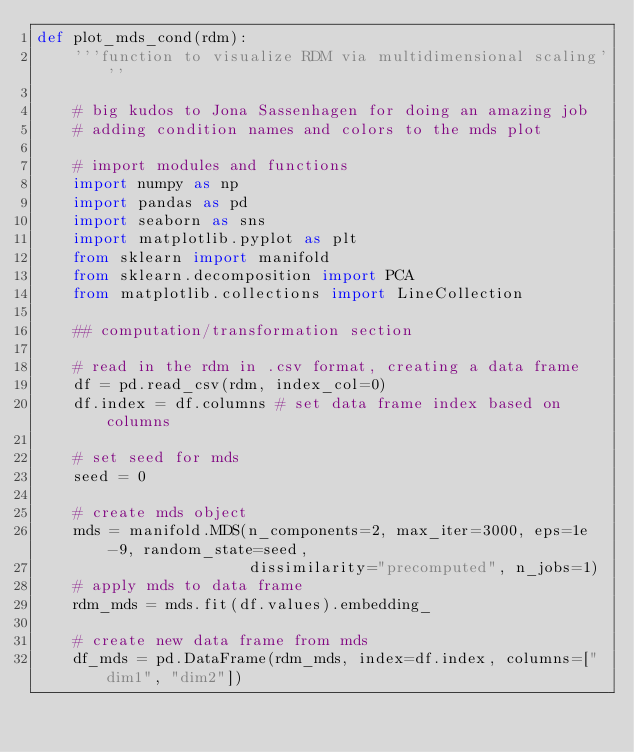Convert code to text. <code><loc_0><loc_0><loc_500><loc_500><_Python_>def plot_mds_cond(rdm):
    '''function to visualize RDM via multidimensional scaling'''

    # big kudos to Jona Sassenhagen for doing an amazing job
    # adding condition names and colors to the mds plot

    # import modules and functions
    import numpy as np
    import pandas as pd
    import seaborn as sns
    import matplotlib.pyplot as plt
    from sklearn import manifold
    from sklearn.decomposition import PCA
    from matplotlib.collections import LineCollection

    ## computation/transformation section

    # read in the rdm in .csv format, creating a data frame
    df = pd.read_csv(rdm, index_col=0)
    df.index = df.columns # set data frame index based on columns

    # set seed for mds
    seed = 0

    # create mds object
    mds = manifold.MDS(n_components=2, max_iter=3000, eps=1e-9, random_state=seed,
                       dissimilarity="precomputed", n_jobs=1)
    # apply mds to data frame
    rdm_mds = mds.fit(df.values).embedding_

    # create new data frame from mds
    df_mds = pd.DataFrame(rdm_mds, index=df.index, columns=["dim1", "dim2"])</code> 